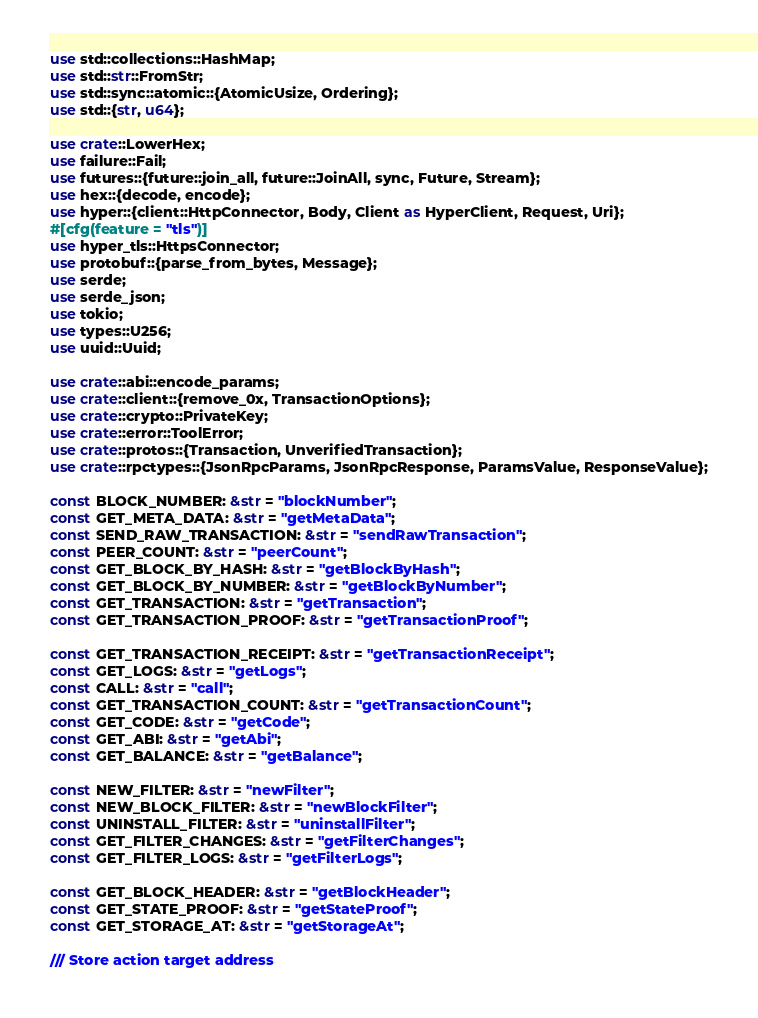Convert code to text. <code><loc_0><loc_0><loc_500><loc_500><_Rust_>use std::collections::HashMap;
use std::str::FromStr;
use std::sync::atomic::{AtomicUsize, Ordering};
use std::{str, u64};

use crate::LowerHex;
use failure::Fail;
use futures::{future::join_all, future::JoinAll, sync, Future, Stream};
use hex::{decode, encode};
use hyper::{client::HttpConnector, Body, Client as HyperClient, Request, Uri};
#[cfg(feature = "tls")]
use hyper_tls::HttpsConnector;
use protobuf::{parse_from_bytes, Message};
use serde;
use serde_json;
use tokio;
use types::U256;
use uuid::Uuid;

use crate::abi::encode_params;
use crate::client::{remove_0x, TransactionOptions};
use crate::crypto::PrivateKey;
use crate::error::ToolError;
use crate::protos::{Transaction, UnverifiedTransaction};
use crate::rpctypes::{JsonRpcParams, JsonRpcResponse, ParamsValue, ResponseValue};

const BLOCK_NUMBER: &str = "blockNumber";
const GET_META_DATA: &str = "getMetaData";
const SEND_RAW_TRANSACTION: &str = "sendRawTransaction";
const PEER_COUNT: &str = "peerCount";
const GET_BLOCK_BY_HASH: &str = "getBlockByHash";
const GET_BLOCK_BY_NUMBER: &str = "getBlockByNumber";
const GET_TRANSACTION: &str = "getTransaction";
const GET_TRANSACTION_PROOF: &str = "getTransactionProof";

const GET_TRANSACTION_RECEIPT: &str = "getTransactionReceipt";
const GET_LOGS: &str = "getLogs";
const CALL: &str = "call";
const GET_TRANSACTION_COUNT: &str = "getTransactionCount";
const GET_CODE: &str = "getCode";
const GET_ABI: &str = "getAbi";
const GET_BALANCE: &str = "getBalance";

const NEW_FILTER: &str = "newFilter";
const NEW_BLOCK_FILTER: &str = "newBlockFilter";
const UNINSTALL_FILTER: &str = "uninstallFilter";
const GET_FILTER_CHANGES: &str = "getFilterChanges";
const GET_FILTER_LOGS: &str = "getFilterLogs";

const GET_BLOCK_HEADER: &str = "getBlockHeader";
const GET_STATE_PROOF: &str = "getStateProof";
const GET_STORAGE_AT: &str = "getStorageAt";

/// Store action target address</code> 